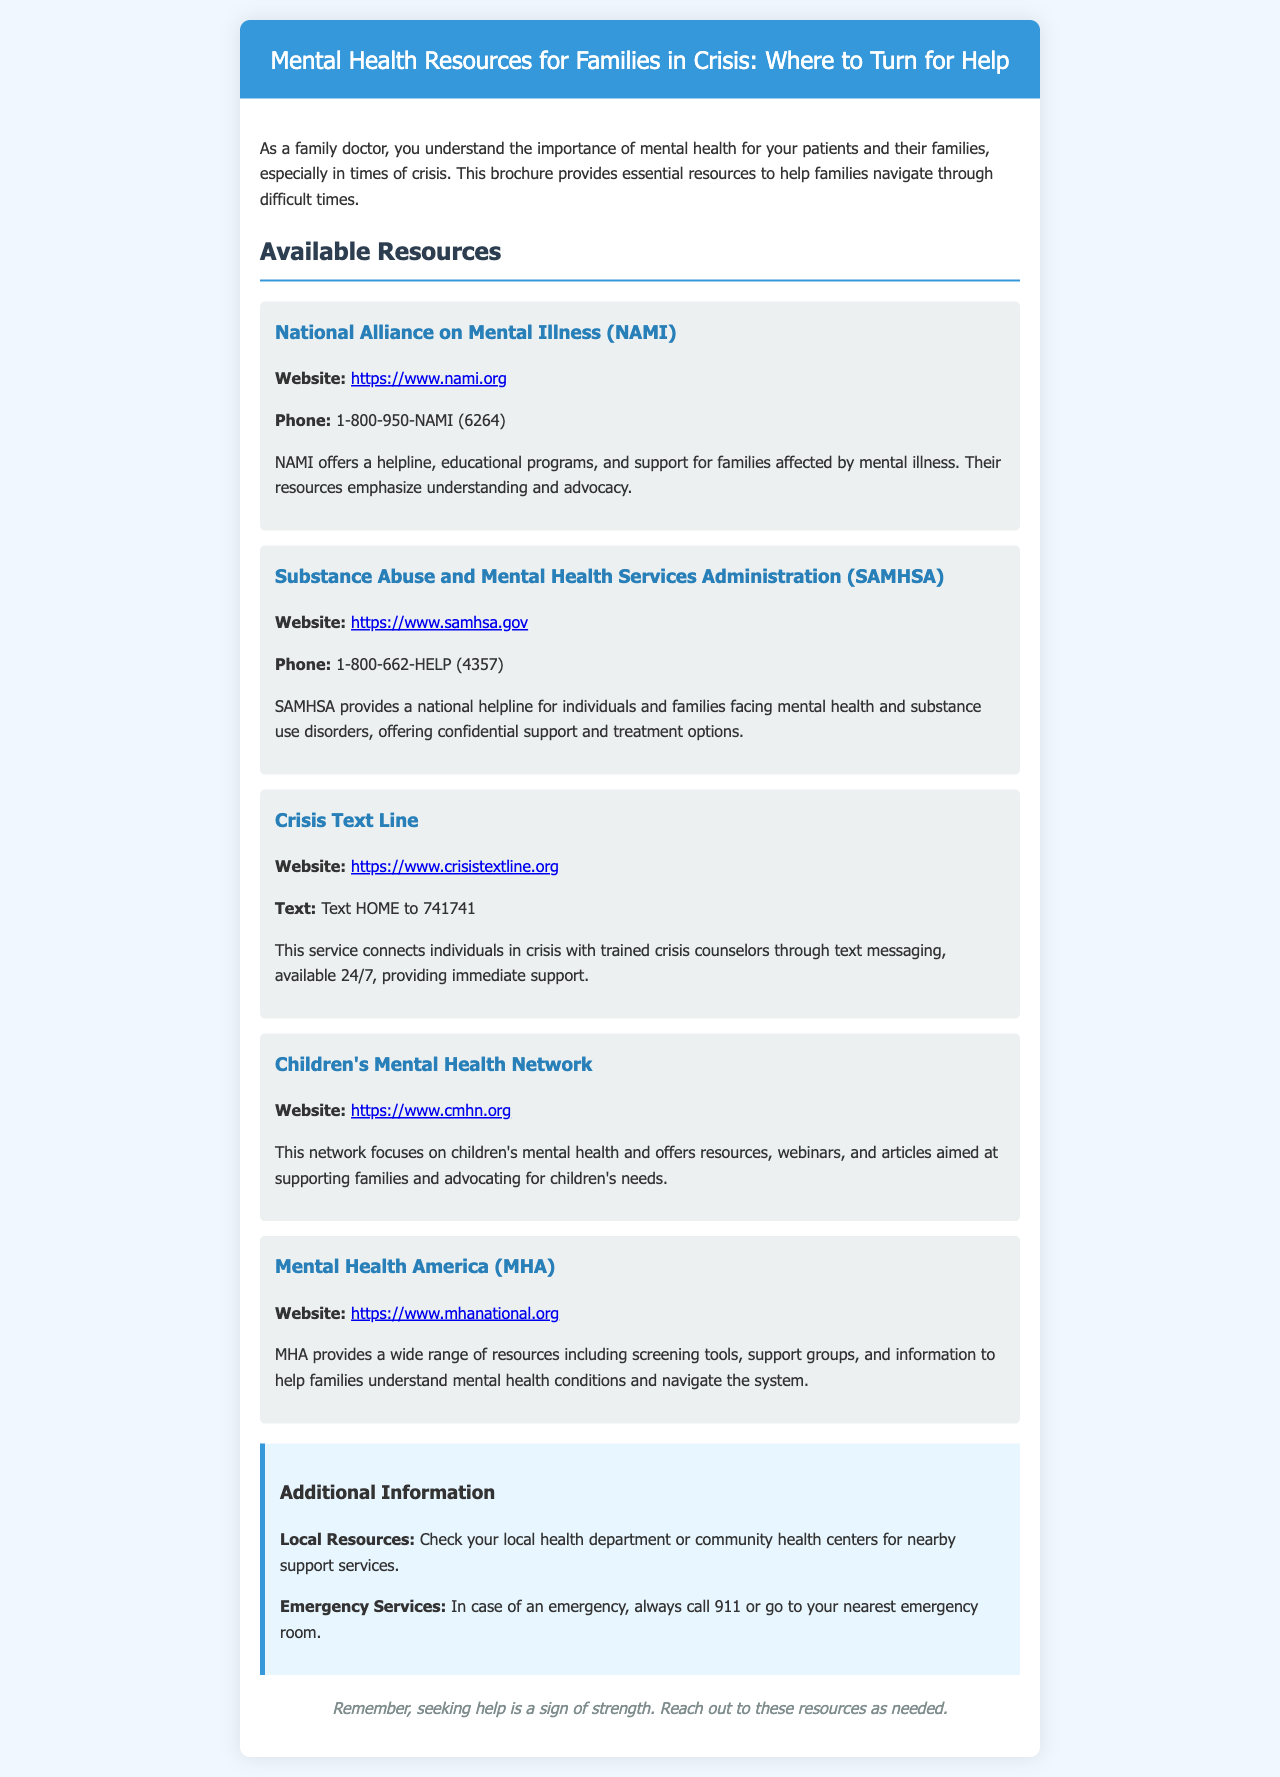what is the website for NAMI? The website for NAMI is given in the resource section of the document.
Answer: https://www.nami.org what is the phone number for SAMHSA? The phone number for SAMHSA is provided in their resource section.
Answer: 1-800-662-HELP how can you text for support from the Crisis Text Line? The document specifies how to contact the Crisis Text Line for support.
Answer: Text HOME to 741741 which organization focuses on children's mental health? The resource section lists organizations, and this organization is specifically mentioned for children's mental health.
Answer: Children's Mental Health Network what type of support does the Crisis Text Line provide? The document explains what kind of support is available through the Crisis Text Line.
Answer: Immediate support why is it important to seek help according to the brochure? The closing statement of the document emphasizes the significance of seeking help.
Answer: Sign of strength how many resources are listed in the brochure? The document outlines several resources under the "Available Resources" section, and this is asking for their count.
Answer: Five what should you do in case of an emergency? The document gives specific advice for emergency situations.
Answer: Call 911 